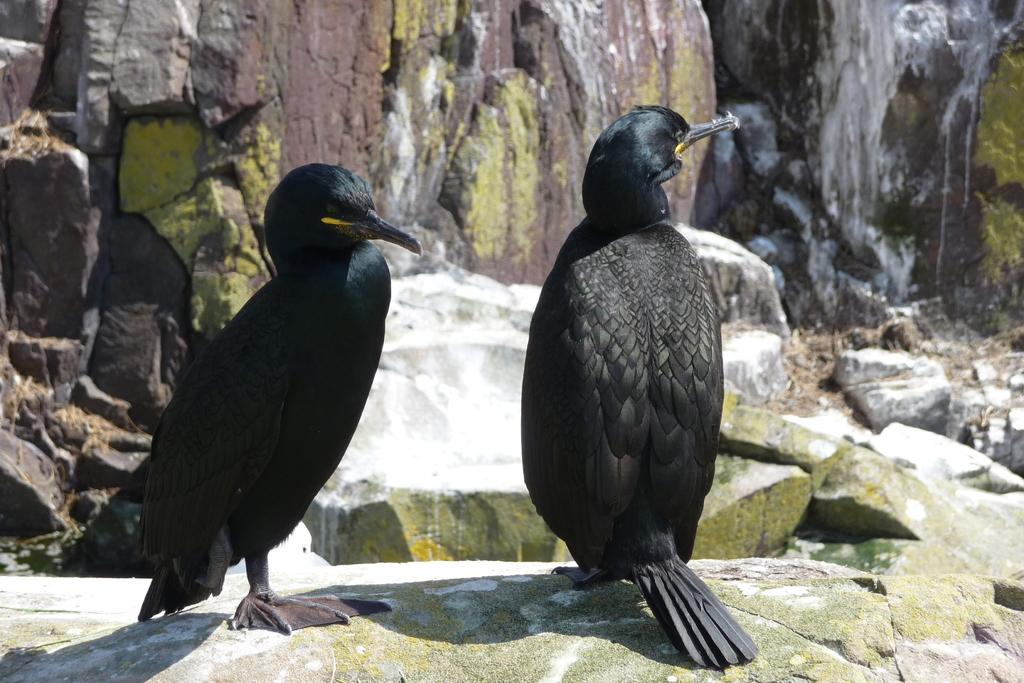What type of animals are present in the image? There are two black birds in the image. What are the birds standing on? The birds are standing on rocks. Can you see any geese in the image? No, there are no geese present in the image; only two black birds are visible. What is the birds' state of mind in the image? The birds' state of mind cannot be determined from the image, as it does not provide information about their emotions or thoughts. 